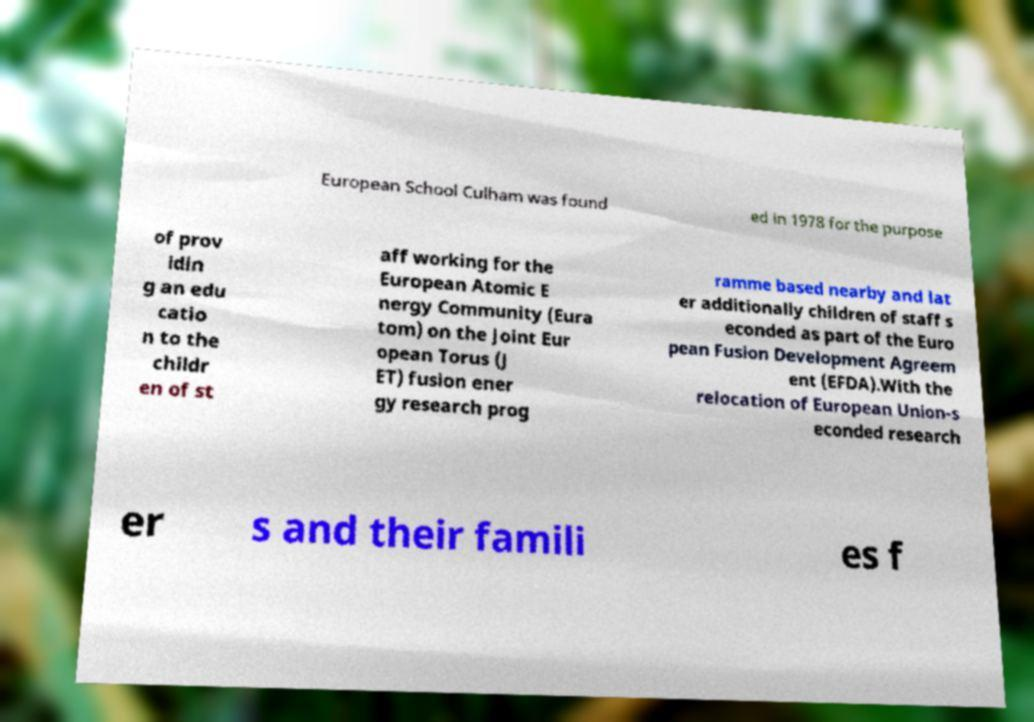Could you assist in decoding the text presented in this image and type it out clearly? European School Culham was found ed in 1978 for the purpose of prov idin g an edu catio n to the childr en of st aff working for the European Atomic E nergy Community (Eura tom) on the Joint Eur opean Torus (J ET) fusion ener gy research prog ramme based nearby and lat er additionally children of staff s econded as part of the Euro pean Fusion Development Agreem ent (EFDA).With the relocation of European Union-s econded research er s and their famili es f 